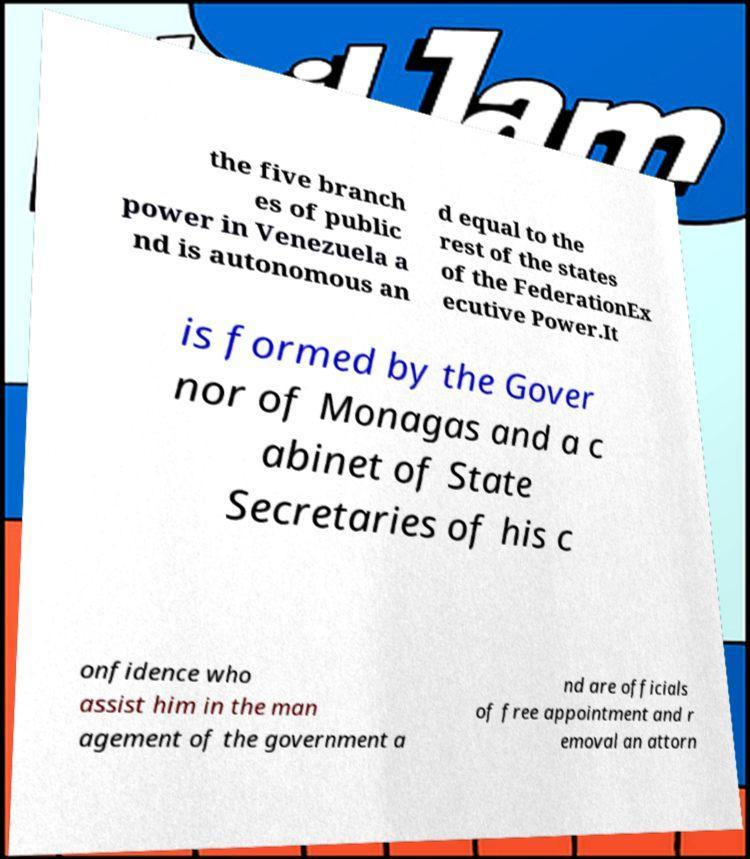Can you accurately transcribe the text from the provided image for me? the five branch es of public power in Venezuela a nd is autonomous an d equal to the rest of the states of the FederationEx ecutive Power.It is formed by the Gover nor of Monagas and a c abinet of State Secretaries of his c onfidence who assist him in the man agement of the government a nd are officials of free appointment and r emoval an attorn 